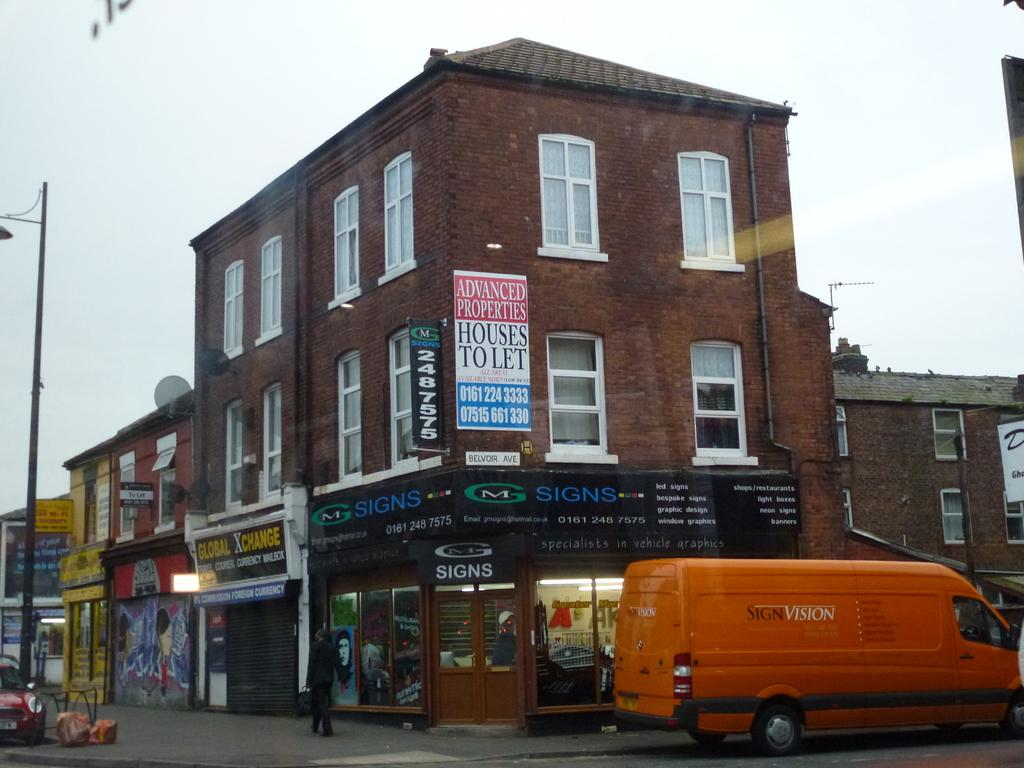What type of building can be seen in the image? There is a brown building in the image. What color is the van on the road? The van on the road is orange in color. What color is the car on the left side of the image? The car on the left side of the image is red. What is visible at the top of the image? The sky is visible at the top of the image. Where is the mine located in the image? There is no mine present in the image. What type of locket is the person wearing in the image? There are no people or lockets visible in the image. 